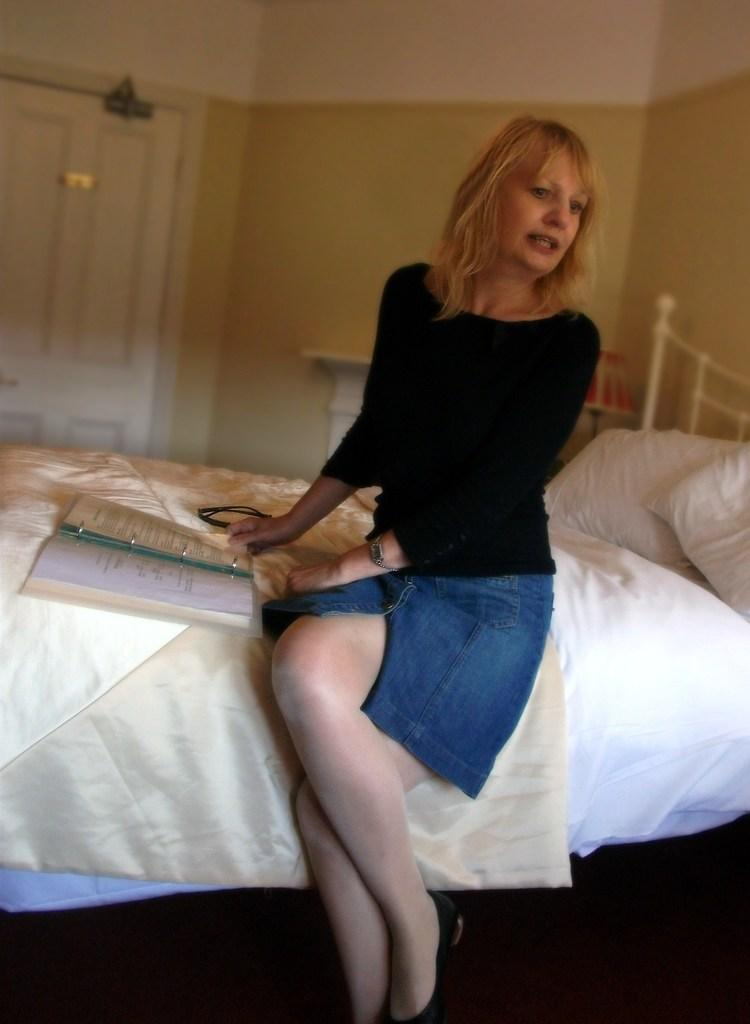Who is present in the image? There is a woman in the image. What is the woman doing in the image? The woman is sitting on the bed and holding a book. What can be seen on the bed besides the woman? There are pillows in the image. What architectural feature is visible in the image? There is a door visible in the image, and it is connected to a wall. What is the price of the mark on the door in the image? There is no mark on the door in the image, and therefore no price can be associated with it. 